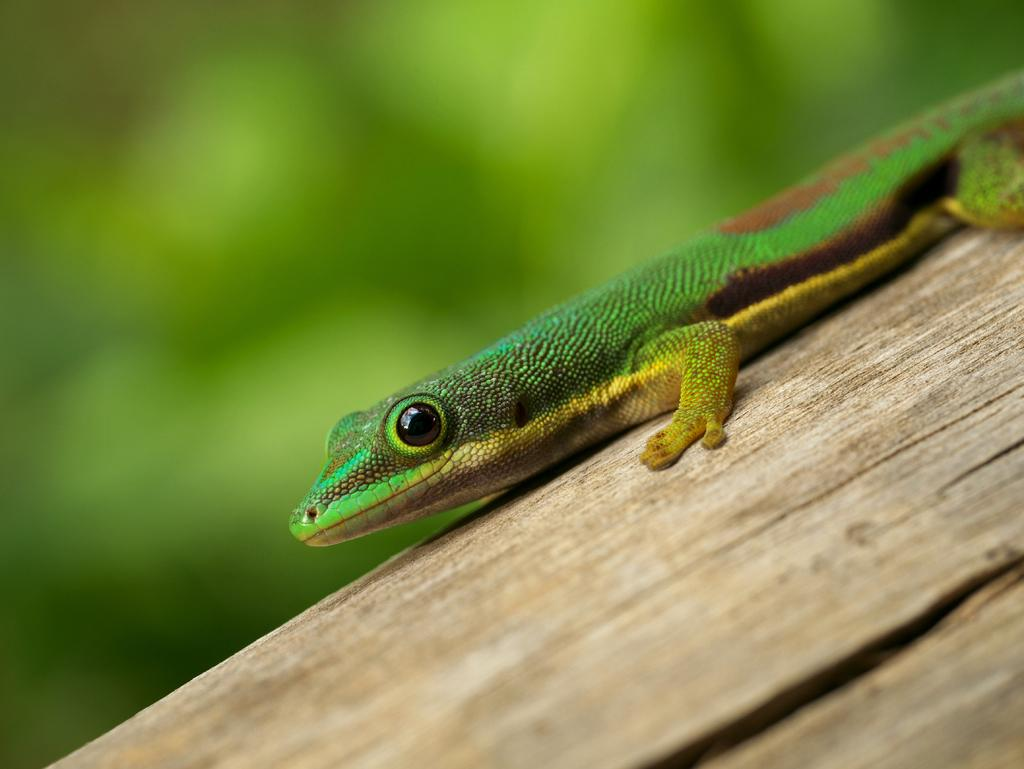What type of animal is in the picture? There is a lizard in the picture. How does the lizard appear to be feeling? The lizard appears to be angry or displaying a similar emotion. Where is the lizard located in the image? The lizard is on a tree trunk. Can you describe the background of the image? The background of the image is blurred. What type of wealth can be seen in the image? There is no wealth present in the image; it features a lizard on a tree trunk. What type of patch is visible on the lizard's back? There is no patch visible on the lizard's back in the image. 